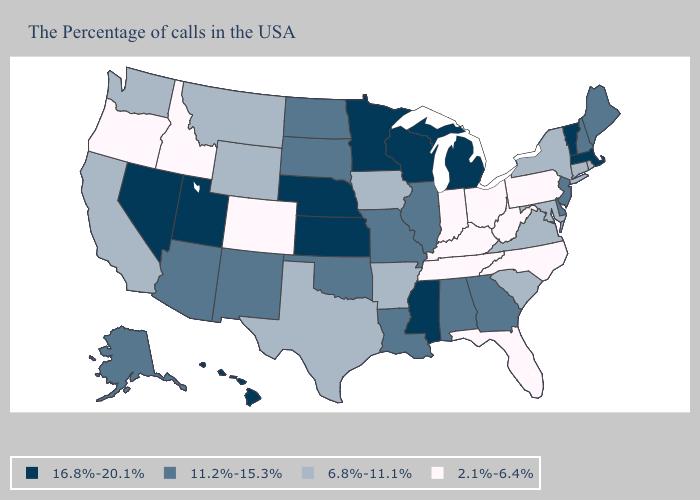Name the states that have a value in the range 11.2%-15.3%?
Concise answer only. Maine, New Hampshire, New Jersey, Delaware, Georgia, Alabama, Illinois, Louisiana, Missouri, Oklahoma, South Dakota, North Dakota, New Mexico, Arizona, Alaska. Does West Virginia have the highest value in the USA?
Answer briefly. No. What is the value of Colorado?
Short answer required. 2.1%-6.4%. Which states have the highest value in the USA?
Write a very short answer. Massachusetts, Vermont, Michigan, Wisconsin, Mississippi, Minnesota, Kansas, Nebraska, Utah, Nevada, Hawaii. What is the value of California?
Keep it brief. 6.8%-11.1%. What is the highest value in states that border Colorado?
Short answer required. 16.8%-20.1%. Does Florida have the lowest value in the USA?
Give a very brief answer. Yes. What is the value of Connecticut?
Write a very short answer. 6.8%-11.1%. Does Vermont have the highest value in the USA?
Write a very short answer. Yes. Which states hav the highest value in the MidWest?
Quick response, please. Michigan, Wisconsin, Minnesota, Kansas, Nebraska. Among the states that border Maryland , which have the lowest value?
Write a very short answer. Pennsylvania, West Virginia. Does the first symbol in the legend represent the smallest category?
Short answer required. No. What is the lowest value in states that border Kansas?
Answer briefly. 2.1%-6.4%. What is the value of Delaware?
Be succinct. 11.2%-15.3%. What is the value of Oklahoma?
Give a very brief answer. 11.2%-15.3%. 